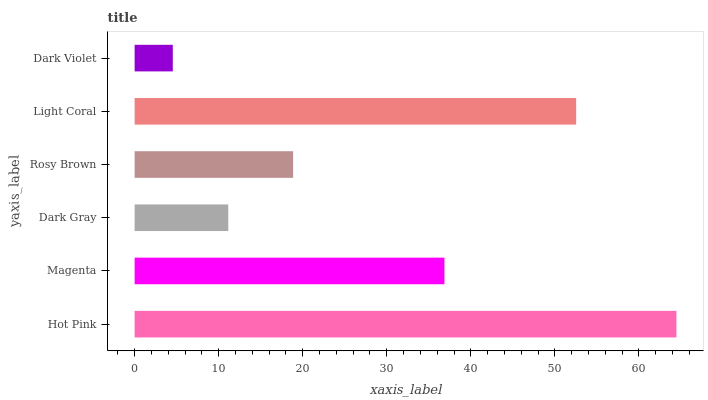Is Dark Violet the minimum?
Answer yes or no. Yes. Is Hot Pink the maximum?
Answer yes or no. Yes. Is Magenta the minimum?
Answer yes or no. No. Is Magenta the maximum?
Answer yes or no. No. Is Hot Pink greater than Magenta?
Answer yes or no. Yes. Is Magenta less than Hot Pink?
Answer yes or no. Yes. Is Magenta greater than Hot Pink?
Answer yes or no. No. Is Hot Pink less than Magenta?
Answer yes or no. No. Is Magenta the high median?
Answer yes or no. Yes. Is Rosy Brown the low median?
Answer yes or no. Yes. Is Rosy Brown the high median?
Answer yes or no. No. Is Light Coral the low median?
Answer yes or no. No. 